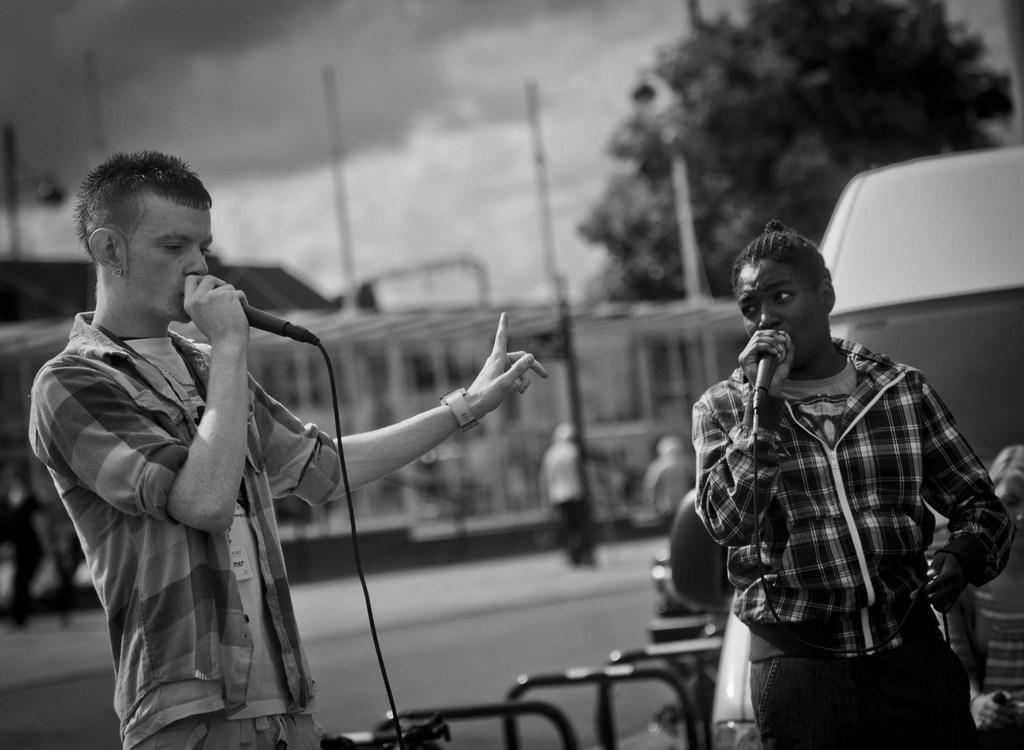Describe this image in one or two sentences. Black and white picture. Front these two people are holding mics near their mouths. Background it is blur. We can see people, sky and tree. Here we can see vehicle. 